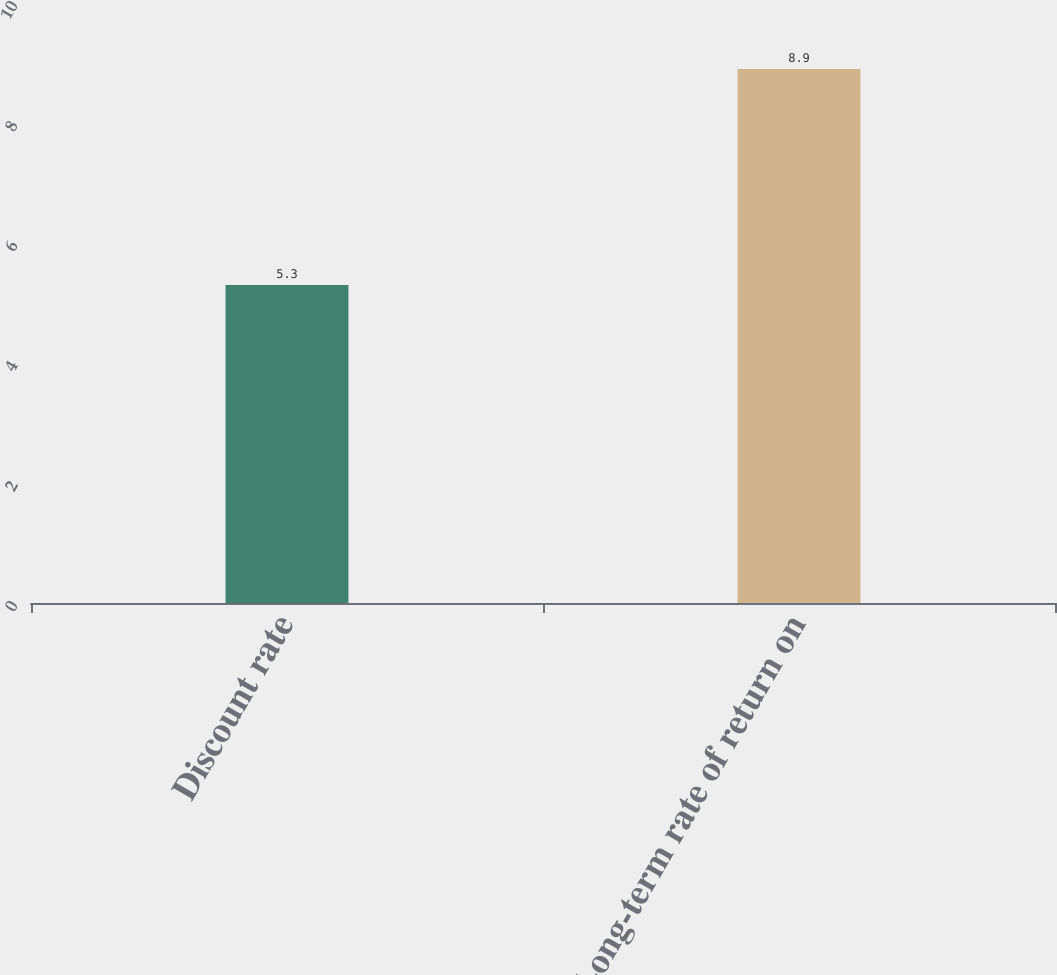Convert chart to OTSL. <chart><loc_0><loc_0><loc_500><loc_500><bar_chart><fcel>Discount rate<fcel>Long-term rate of return on<nl><fcel>5.3<fcel>8.9<nl></chart> 